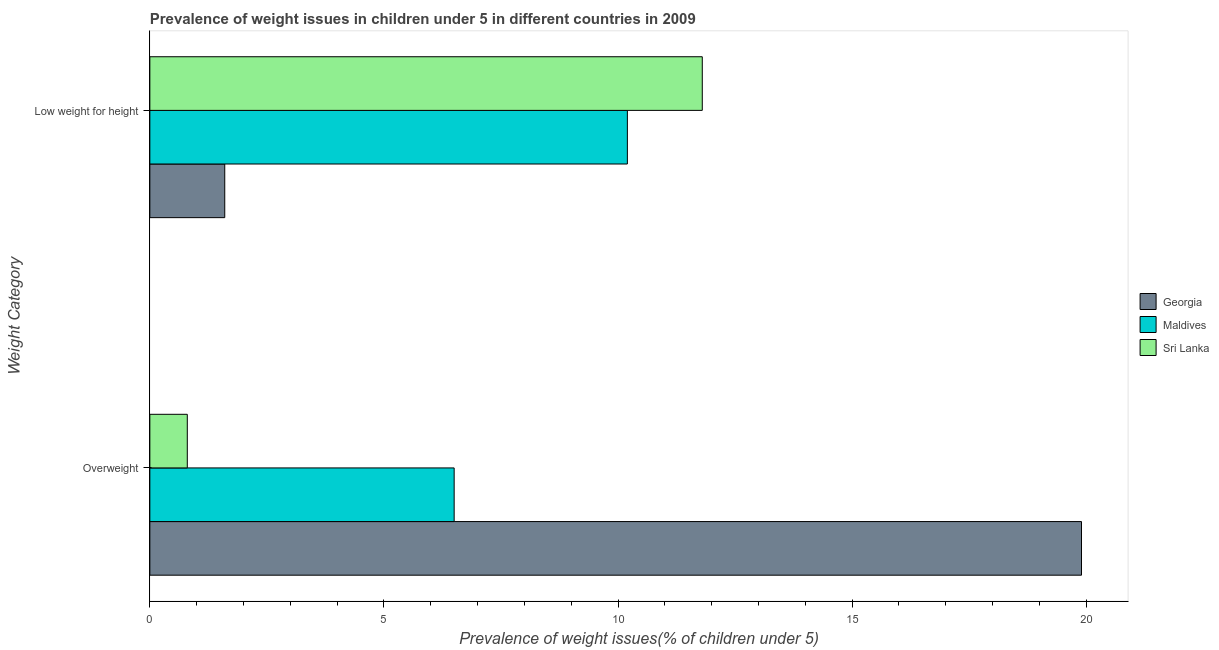How many groups of bars are there?
Provide a succinct answer. 2. How many bars are there on the 2nd tick from the bottom?
Your answer should be compact. 3. What is the label of the 1st group of bars from the top?
Ensure brevity in your answer.  Low weight for height. What is the percentage of overweight children in Maldives?
Your response must be concise. 6.5. Across all countries, what is the maximum percentage of overweight children?
Make the answer very short. 19.9. Across all countries, what is the minimum percentage of underweight children?
Ensure brevity in your answer.  1.6. In which country was the percentage of overweight children maximum?
Your answer should be compact. Georgia. In which country was the percentage of overweight children minimum?
Give a very brief answer. Sri Lanka. What is the total percentage of underweight children in the graph?
Offer a very short reply. 23.6. What is the difference between the percentage of underweight children in Georgia and that in Sri Lanka?
Offer a terse response. -10.2. What is the difference between the percentage of underweight children in Georgia and the percentage of overweight children in Maldives?
Your answer should be compact. -4.9. What is the average percentage of underweight children per country?
Provide a succinct answer. 7.87. What is the difference between the percentage of overweight children and percentage of underweight children in Maldives?
Offer a terse response. -3.7. What is the ratio of the percentage of underweight children in Sri Lanka to that in Georgia?
Make the answer very short. 7.38. Is the percentage of underweight children in Georgia less than that in Maldives?
Give a very brief answer. Yes. What does the 2nd bar from the top in Low weight for height represents?
Offer a terse response. Maldives. What does the 3rd bar from the bottom in Low weight for height represents?
Provide a succinct answer. Sri Lanka. How many bars are there?
Provide a succinct answer. 6. How many countries are there in the graph?
Ensure brevity in your answer.  3. What is the difference between two consecutive major ticks on the X-axis?
Provide a short and direct response. 5. Where does the legend appear in the graph?
Your answer should be very brief. Center right. How many legend labels are there?
Your answer should be very brief. 3. What is the title of the graph?
Give a very brief answer. Prevalence of weight issues in children under 5 in different countries in 2009. Does "Virgin Islands" appear as one of the legend labels in the graph?
Provide a succinct answer. No. What is the label or title of the X-axis?
Your response must be concise. Prevalence of weight issues(% of children under 5). What is the label or title of the Y-axis?
Keep it short and to the point. Weight Category. What is the Prevalence of weight issues(% of children under 5) in Georgia in Overweight?
Your answer should be compact. 19.9. What is the Prevalence of weight issues(% of children under 5) in Maldives in Overweight?
Provide a short and direct response. 6.5. What is the Prevalence of weight issues(% of children under 5) in Sri Lanka in Overweight?
Offer a very short reply. 0.8. What is the Prevalence of weight issues(% of children under 5) of Georgia in Low weight for height?
Provide a succinct answer. 1.6. What is the Prevalence of weight issues(% of children under 5) of Maldives in Low weight for height?
Make the answer very short. 10.2. What is the Prevalence of weight issues(% of children under 5) in Sri Lanka in Low weight for height?
Offer a terse response. 11.8. Across all Weight Category, what is the maximum Prevalence of weight issues(% of children under 5) in Georgia?
Give a very brief answer. 19.9. Across all Weight Category, what is the maximum Prevalence of weight issues(% of children under 5) in Maldives?
Keep it short and to the point. 10.2. Across all Weight Category, what is the maximum Prevalence of weight issues(% of children under 5) of Sri Lanka?
Your response must be concise. 11.8. Across all Weight Category, what is the minimum Prevalence of weight issues(% of children under 5) in Georgia?
Your response must be concise. 1.6. Across all Weight Category, what is the minimum Prevalence of weight issues(% of children under 5) of Maldives?
Make the answer very short. 6.5. Across all Weight Category, what is the minimum Prevalence of weight issues(% of children under 5) in Sri Lanka?
Offer a terse response. 0.8. What is the total Prevalence of weight issues(% of children under 5) in Georgia in the graph?
Offer a terse response. 21.5. What is the total Prevalence of weight issues(% of children under 5) in Maldives in the graph?
Keep it short and to the point. 16.7. What is the total Prevalence of weight issues(% of children under 5) of Sri Lanka in the graph?
Your answer should be very brief. 12.6. What is the difference between the Prevalence of weight issues(% of children under 5) of Maldives in Overweight and that in Low weight for height?
Offer a very short reply. -3.7. What is the difference between the Prevalence of weight issues(% of children under 5) in Sri Lanka in Overweight and that in Low weight for height?
Provide a short and direct response. -11. What is the difference between the Prevalence of weight issues(% of children under 5) of Georgia in Overweight and the Prevalence of weight issues(% of children under 5) of Maldives in Low weight for height?
Provide a short and direct response. 9.7. What is the difference between the Prevalence of weight issues(% of children under 5) of Georgia in Overweight and the Prevalence of weight issues(% of children under 5) of Sri Lanka in Low weight for height?
Your answer should be very brief. 8.1. What is the difference between the Prevalence of weight issues(% of children under 5) in Maldives in Overweight and the Prevalence of weight issues(% of children under 5) in Sri Lanka in Low weight for height?
Your answer should be very brief. -5.3. What is the average Prevalence of weight issues(% of children under 5) in Georgia per Weight Category?
Make the answer very short. 10.75. What is the average Prevalence of weight issues(% of children under 5) of Maldives per Weight Category?
Provide a short and direct response. 8.35. What is the average Prevalence of weight issues(% of children under 5) of Sri Lanka per Weight Category?
Your response must be concise. 6.3. What is the difference between the Prevalence of weight issues(% of children under 5) of Georgia and Prevalence of weight issues(% of children under 5) of Maldives in Low weight for height?
Provide a succinct answer. -8.6. What is the difference between the Prevalence of weight issues(% of children under 5) of Georgia and Prevalence of weight issues(% of children under 5) of Sri Lanka in Low weight for height?
Make the answer very short. -10.2. What is the difference between the Prevalence of weight issues(% of children under 5) of Maldives and Prevalence of weight issues(% of children under 5) of Sri Lanka in Low weight for height?
Offer a terse response. -1.6. What is the ratio of the Prevalence of weight issues(% of children under 5) in Georgia in Overweight to that in Low weight for height?
Your answer should be compact. 12.44. What is the ratio of the Prevalence of weight issues(% of children under 5) of Maldives in Overweight to that in Low weight for height?
Offer a very short reply. 0.64. What is the ratio of the Prevalence of weight issues(% of children under 5) in Sri Lanka in Overweight to that in Low weight for height?
Give a very brief answer. 0.07. What is the difference between the highest and the lowest Prevalence of weight issues(% of children under 5) in Maldives?
Keep it short and to the point. 3.7. 